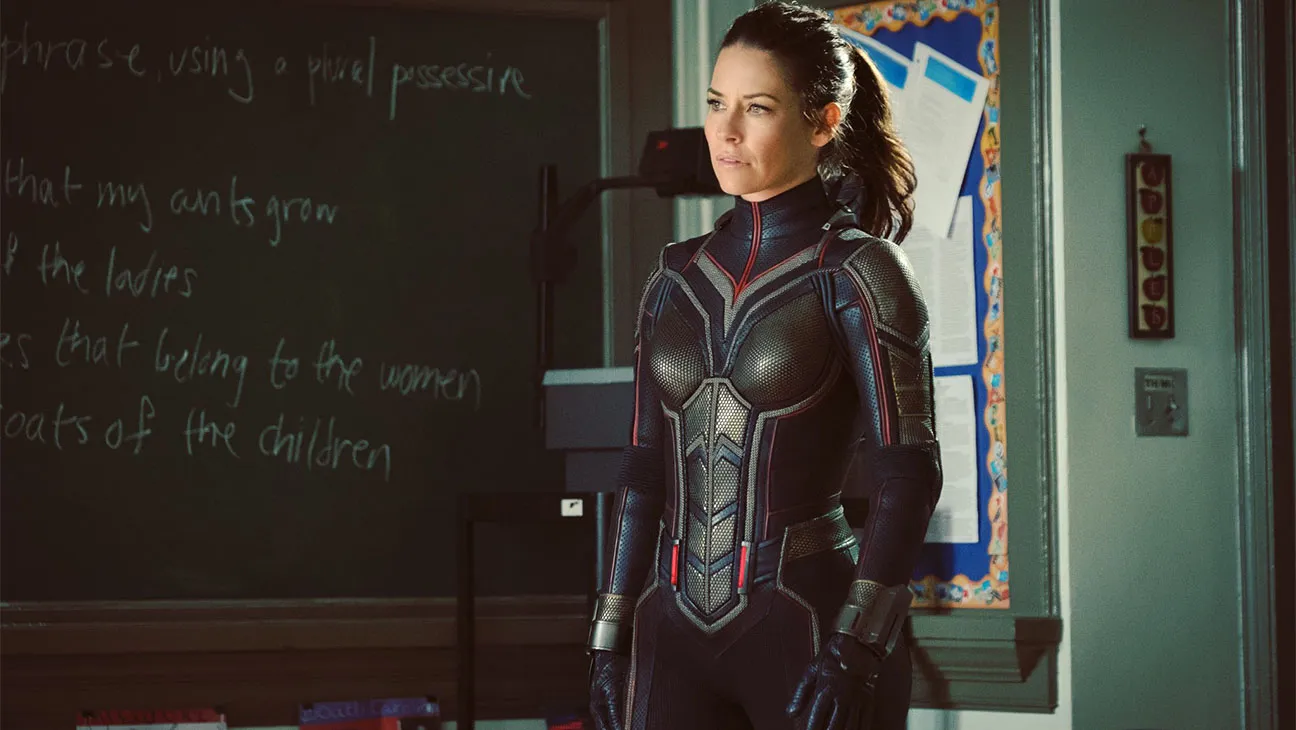Write a dialogue between the character and someone else in the classroom. Character: 'We don’t have much time. The threat is real, and it’s headed our way. I need everyone to stay calm and follow my instructions precisely.'
Student: 'What can we do to help?'
Character: 'Stay alert and be ready to move on my signal. If anything happens, use the emergency exits and head to the safe zone marked on your maps. And remember, trust in your abilities. We will get through this.' What could be the most surprising secret about this character? The most surprising secret about this character could be that she was once a student at this very school, where she first discovered her unique abilities. This personal connection to the setting adds a poignant layer to her mission, as she fights to protect a place that holds significant memories and shaped her journey into becoming a hero. This twist could reveal deeper emotional stakes in the story, blending her past and present in a compelling way.  Envision a backstory for the character that justifies her presence in the classroom. The character grew up in a small town, attending the very school she's now protecting. Her early life was challenging, filled with struggles and adversities. However, she always had a strong sense of justice and a desire to help others. When she discovered her abilities, she dedicated herself to mastering them and used them to protect her community. Returning to the classroom setting, she battles to safeguard the younger generation, determined to prevent them from experiencing the hardships she faced. Thus, her presence here is not just a random mission but a deeply personal quest to give back to the place that once sheltered her dreams. 